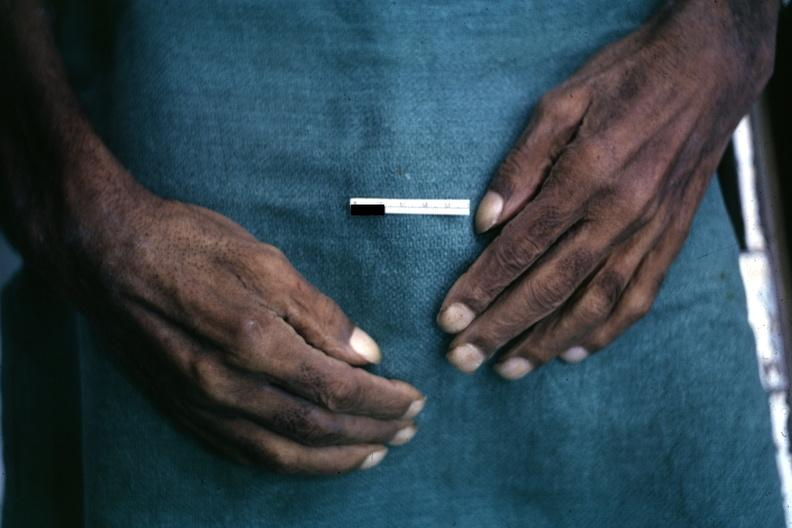re extremities present?
Answer the question using a single word or phrase. Yes 